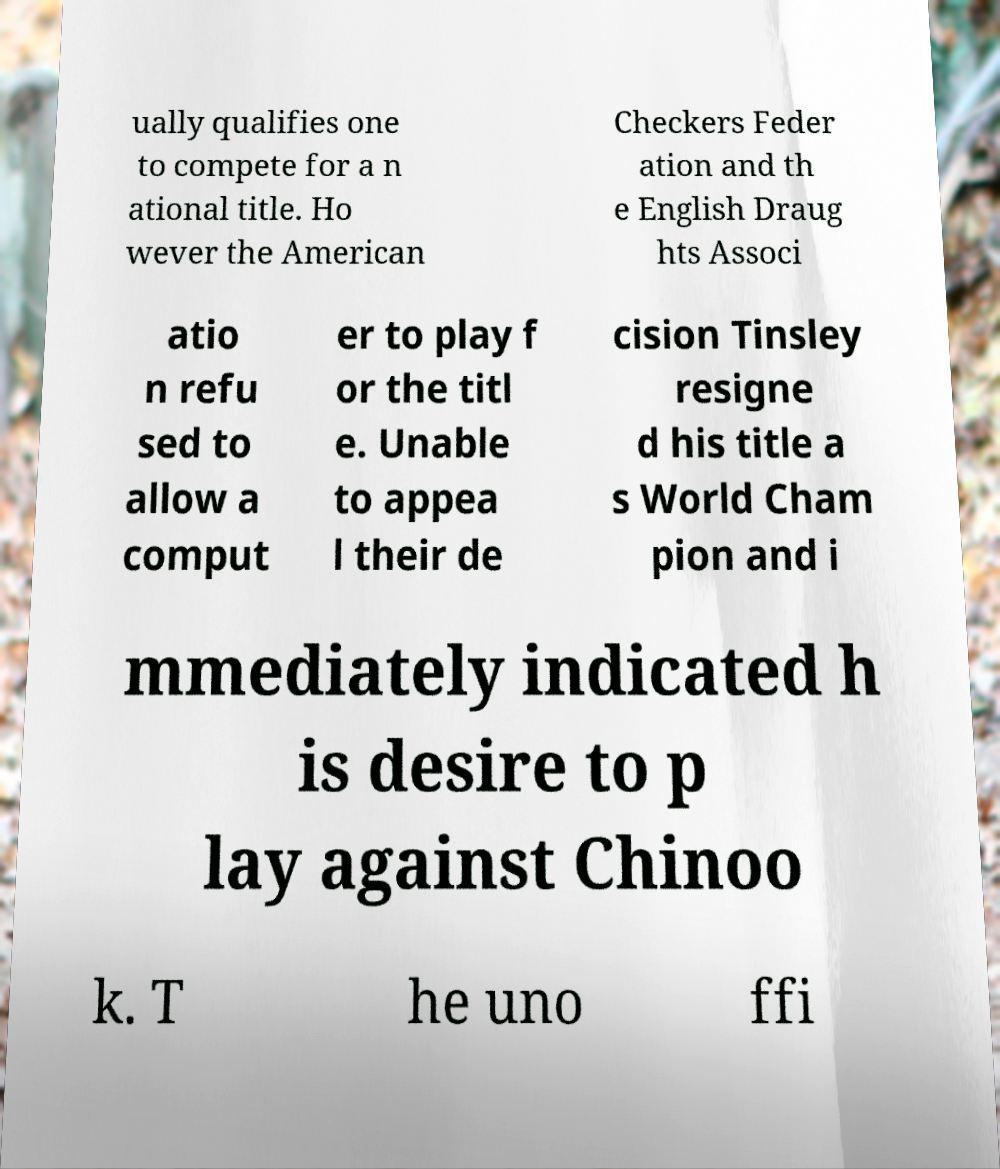For documentation purposes, I need the text within this image transcribed. Could you provide that? ually qualifies one to compete for a n ational title. Ho wever the American Checkers Feder ation and th e English Draug hts Associ atio n refu sed to allow a comput er to play f or the titl e. Unable to appea l their de cision Tinsley resigne d his title a s World Cham pion and i mmediately indicated h is desire to p lay against Chinoo k. T he uno ffi 